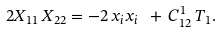<formula> <loc_0><loc_0><loc_500><loc_500>2 X _ { 1 1 } \, X _ { 2 2 } = - 2 \, x _ { i } x _ { i } \ + \, C _ { 1 2 } ^ { 1 } \, T _ { 1 } .</formula> 